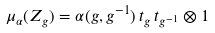<formula> <loc_0><loc_0><loc_500><loc_500>\mu _ { \alpha } ( Z _ { g } ) = \alpha ( g , g ^ { - 1 } ) \, t _ { g } \, t _ { g ^ { - 1 } } \otimes 1</formula> 